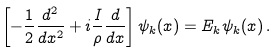Convert formula to latex. <formula><loc_0><loc_0><loc_500><loc_500>\left [ - \frac { 1 } { 2 } \frac { d ^ { 2 } } { d x ^ { 2 } } + i \frac { I } { \rho } \frac { d } { d x } \right ] \psi _ { k } ( x ) = E _ { k } \psi _ { k } ( x ) \, .</formula> 